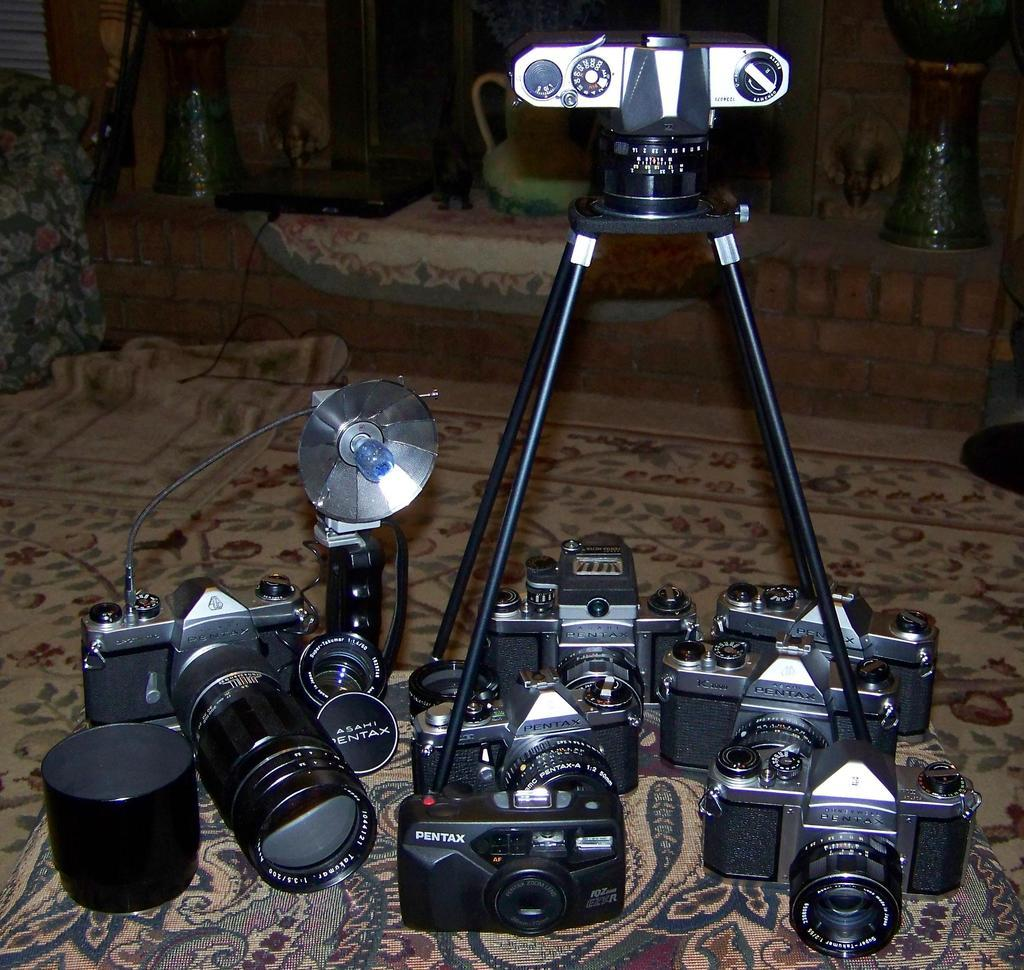What type of equipment is visible in the image? There are many cameras in the image. What additional object can be seen in the image? There is a flashlight in the image. Is there any support equipment for the cameras? Yes, there is a camera stand in the image. What is the surface on which the objects are placed? The objects are placed on a carpet. What other objects can be seen in the background of the image? There is a lantern and a jug in the background of the image. What type of agreement is being discussed in the image? There is no discussion or agreement present in the image; it features cameras, a flashlight, a camera stand, a carpet, a lantern, and a jug. 